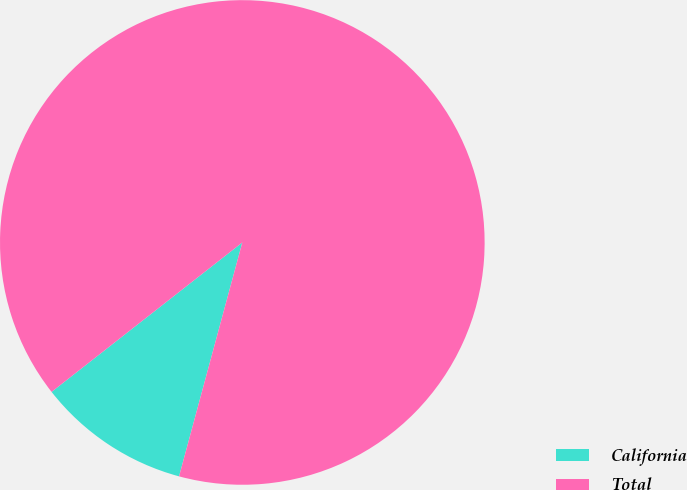Convert chart. <chart><loc_0><loc_0><loc_500><loc_500><pie_chart><fcel>California<fcel>Total<nl><fcel>10.22%<fcel>89.78%<nl></chart> 